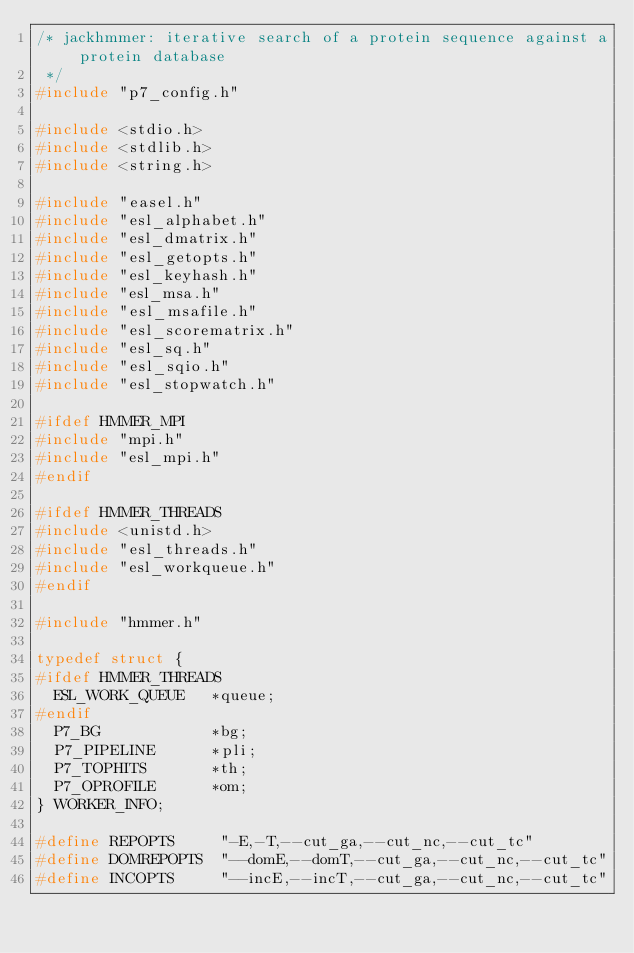Convert code to text. <code><loc_0><loc_0><loc_500><loc_500><_C_>/* jackhmmer: iterative search of a protein sequence against a protein database
 */
#include "p7_config.h"

#include <stdio.h>
#include <stdlib.h>
#include <string.h>

#include "easel.h"
#include "esl_alphabet.h"
#include "esl_dmatrix.h"
#include "esl_getopts.h"
#include "esl_keyhash.h"
#include "esl_msa.h"
#include "esl_msafile.h"
#include "esl_scorematrix.h"
#include "esl_sq.h"
#include "esl_sqio.h"
#include "esl_stopwatch.h"

#ifdef HMMER_MPI
#include "mpi.h"
#include "esl_mpi.h"
#endif 

#ifdef HMMER_THREADS
#include <unistd.h>
#include "esl_threads.h"
#include "esl_workqueue.h"
#endif 

#include "hmmer.h"

typedef struct {
#ifdef HMMER_THREADS
  ESL_WORK_QUEUE   *queue;
#endif
  P7_BG            *bg;
  P7_PIPELINE      *pli;
  P7_TOPHITS       *th;
  P7_OPROFILE      *om;
} WORKER_INFO;

#define REPOPTS     "-E,-T,--cut_ga,--cut_nc,--cut_tc"
#define DOMREPOPTS  "--domE,--domT,--cut_ga,--cut_nc,--cut_tc"
#define INCOPTS     "--incE,--incT,--cut_ga,--cut_nc,--cut_tc"</code> 